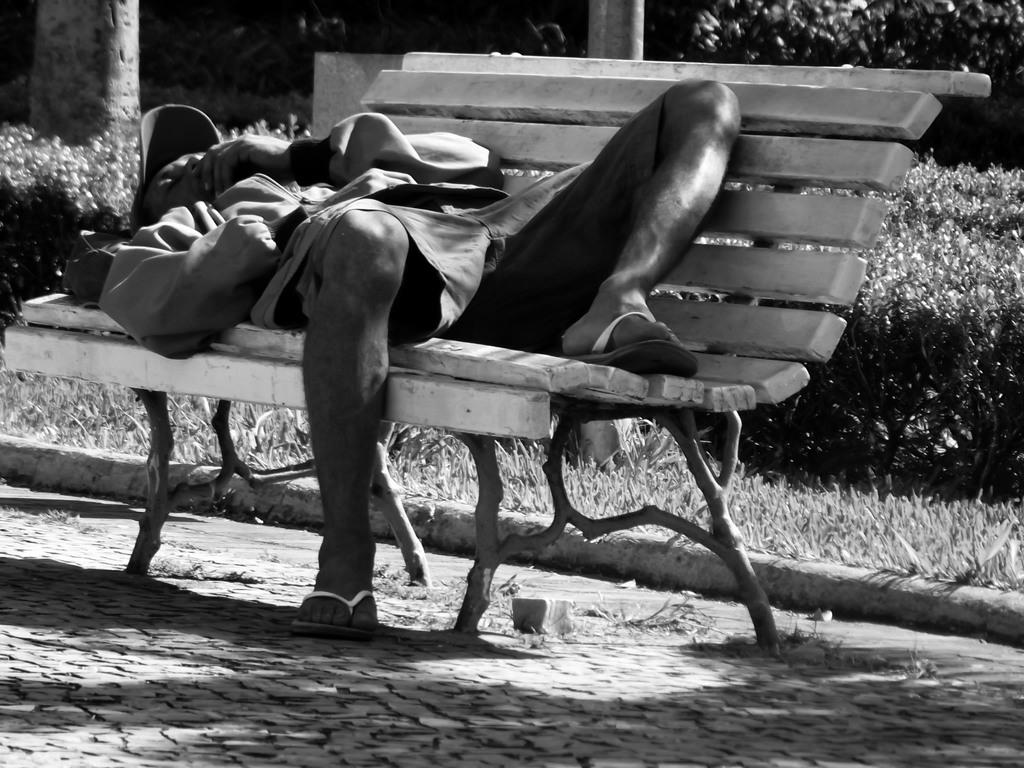What is located in the middle of the image? There is a bench in the middle of the image. What is the man in the image doing? A man is lying on the bench. What can be seen behind the bench in the image? There are trees, plants, and grass behind the bench. What type of pocket can be seen on the man's shirt in the image? There is no pocket visible on the man's shirt in the image. What kind of test is the man taking while lying on the bench? There is no test present in the image; the man is simply lying on the bench. 